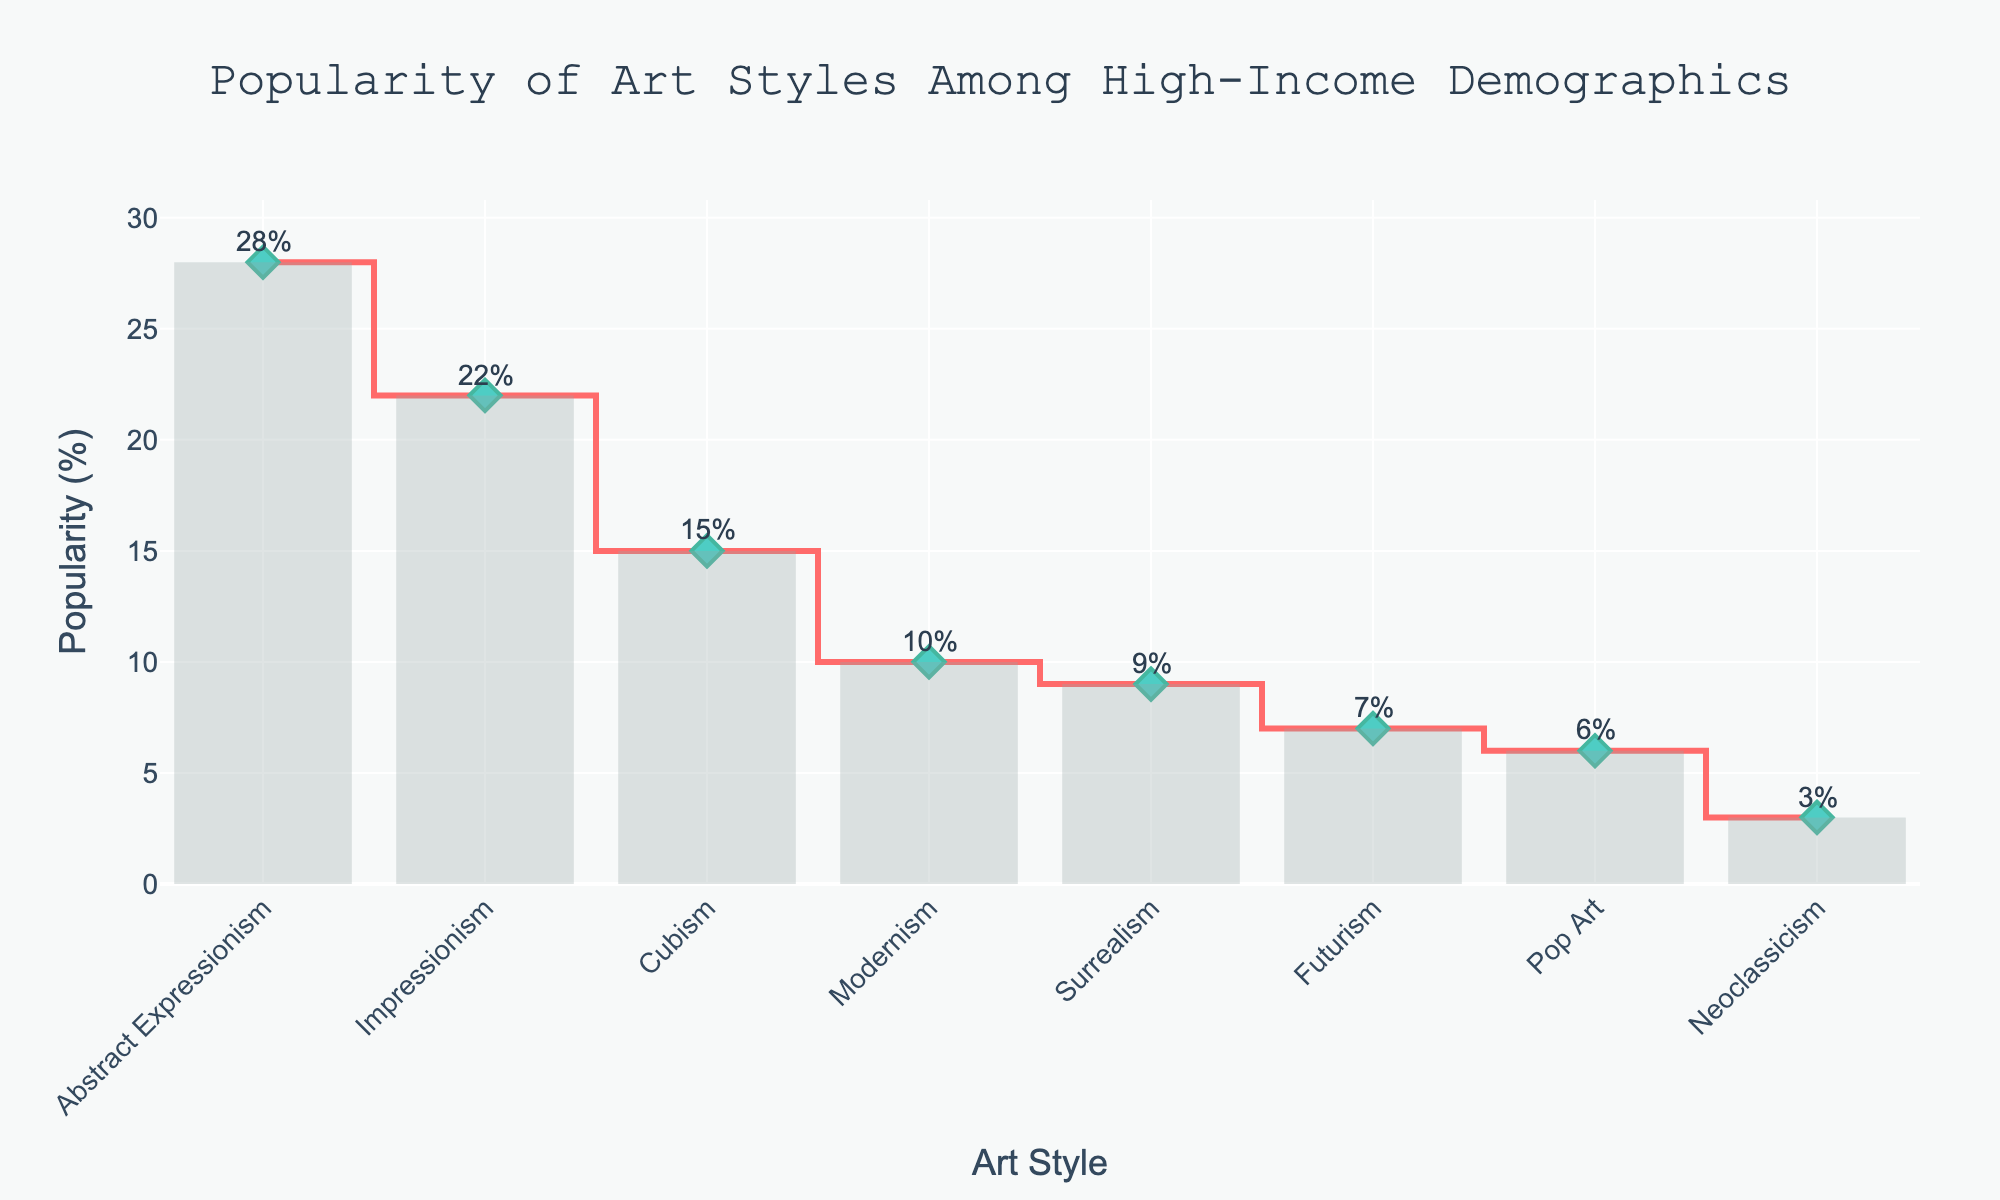What's the title of the plot? The title of the plot is prominently displayed at the top center of the figure.
Answer: Popularity of Art Styles Among High-Income Demographics What percentage of popularity does Abstract Expressionism have? The percentage is labeled at the top of the bar representing Abstract Expressionism in the figure and is also visible when hovering over its marker.
Answer: 28% Which art style has the lowest popularity among high-income demographics? The least popular art style can be found at the end of the sorted list on the x-axis with the lowest bar or data point.
Answer: Neoclassicism How many art styles are shown in the plot? Count the number of distinct art styles listed on the x-axis of the plot.
Answer: 8 What is the combined popularity of Impressionism and Cubism? Extract the percentages for Impressionism and Cubism (22% and 15% respectively), then sum them up: 22 + 15.
Answer: 37% Which art style is more popular, Surrealism or Futurism? Compare the heights of the bars or data points labeled Surrealism and Futurism.
Answer: Surrealism By how much does the popularity of Modernism differ from that of Pop Art? Subtract the percentage of Pop Art from the percentage of Modernism: 10 - 6.
Answer: 4% Which art styles have a popularity of less than 10%? Identify all the art styles with bars or data points representing percentages below 10%.
Answer: Surrealism, Futurism, Pop Art, Neoclassicism What percentage of popularity does the second most popular art style have? Identify the second highest bar or data point and read its labeled percentage.
Answer: 22% Between Abstract Expressionism and Impressionism, which one has more popularity, and by what percentage? Subtract the popularity percentage of Impressionism from that of Abstract Expressionism: 28 - 22 and determine which one is higher.
Answer: Abstract Expressionism, 6% 